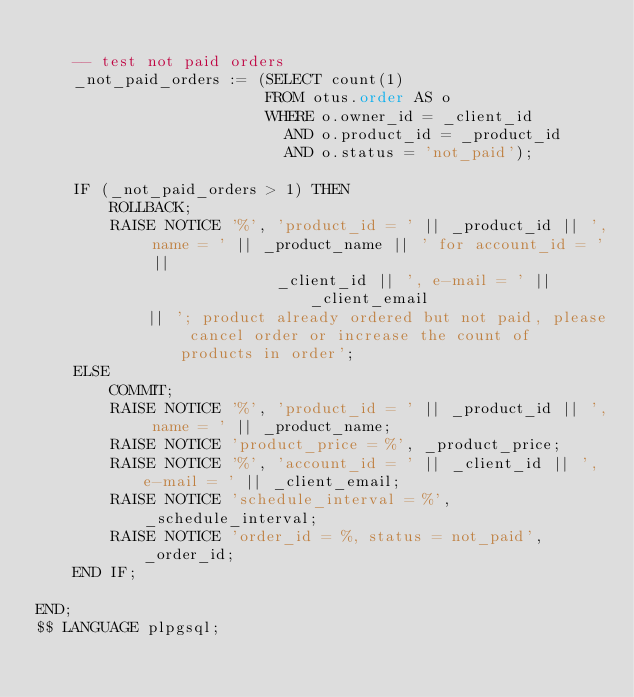<code> <loc_0><loc_0><loc_500><loc_500><_SQL_>
    -- test not paid orders
    _not_paid_orders := (SELECT count(1)
                         FROM otus.order AS o
                         WHERE o.owner_id = _client_id
                           AND o.product_id = _product_id
                           AND o.status = 'not_paid');

    IF (_not_paid_orders > 1) THEN
        ROLLBACK;
        RAISE NOTICE '%', 'product_id = ' || _product_id || ', name = ' || _product_name || ' for account_id = ' ||
                          _client_id || ', e-mail = ' || _client_email
            || '; product already ordered but not paid, please cancel order or increase the count of products in order';
    ELSE
        COMMIT;
        RAISE NOTICE '%', 'product_id = ' || _product_id || ', name = ' || _product_name;
        RAISE NOTICE 'product_price = %', _product_price;
        RAISE NOTICE '%', 'account_id = ' || _client_id || ', e-mail = ' || _client_email;
        RAISE NOTICE 'schedule_interval = %', _schedule_interval;
        RAISE NOTICE 'order_id = %, status = not_paid', _order_id;
    END IF;

END;
$$ LANGUAGE plpgsql;
</code> 